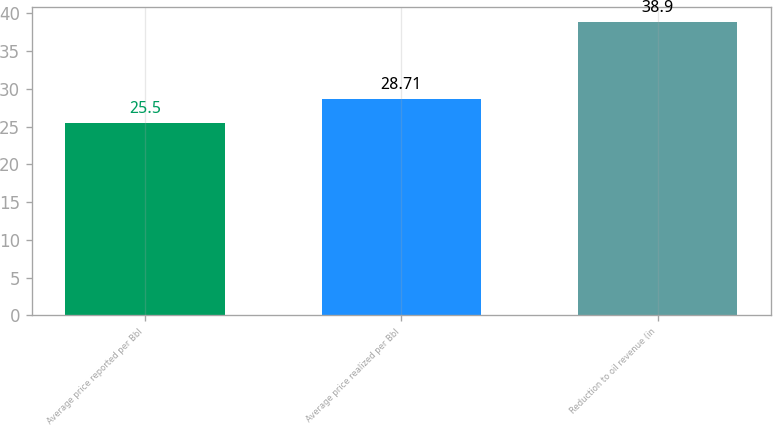<chart> <loc_0><loc_0><loc_500><loc_500><bar_chart><fcel>Average price reported per Bbl<fcel>Average price realized per Bbl<fcel>Reduction to oil revenue (in<nl><fcel>25.5<fcel>28.71<fcel>38.9<nl></chart> 